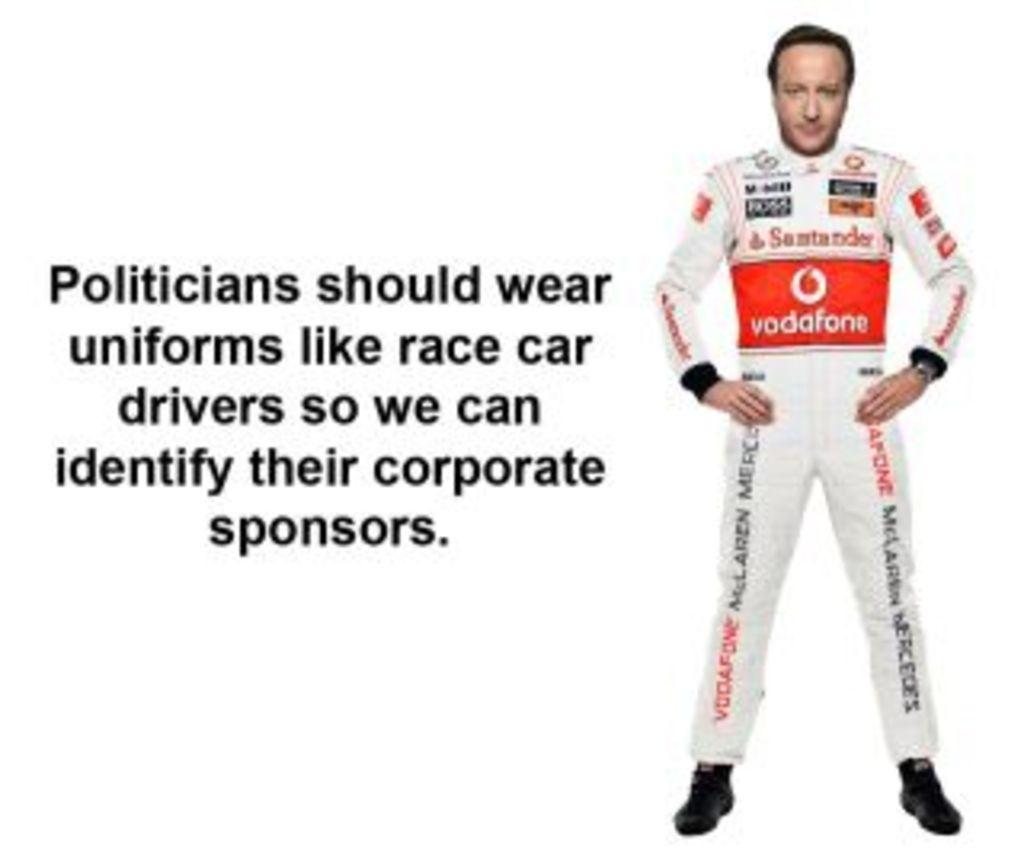<image>
Summarize the visual content of the image. race car driver sponsored by vodafone stands next to a political message 